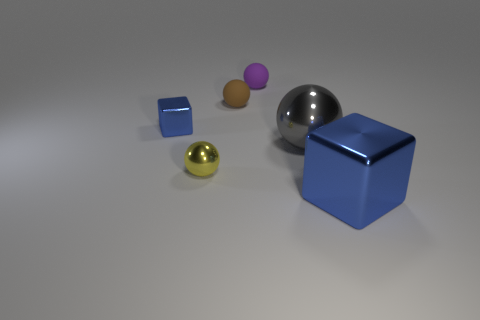Do the small block and the large metallic block have the same color?
Give a very brief answer. Yes. What size is the other metallic cube that is the same color as the large metallic block?
Offer a terse response. Small. Are there fewer tiny yellow metallic things that are right of the tiny purple ball than brown balls right of the small brown sphere?
Offer a terse response. No. Are there any other things that have the same size as the gray object?
Your answer should be compact. Yes. There is a small purple object; what shape is it?
Give a very brief answer. Sphere. What material is the blue block that is left of the tiny purple thing?
Your response must be concise. Metal. There is a metal block right of the tiny shiny thing in front of the blue metallic thing that is on the left side of the large cube; how big is it?
Offer a terse response. Large. Is the material of the blue object that is right of the tiny blue metal object the same as the blue object that is behind the small yellow shiny ball?
Your answer should be compact. Yes. How many other objects are there of the same color as the large cube?
Provide a short and direct response. 1. How many objects are tiny objects on the left side of the small brown sphere or blocks that are to the right of the tiny brown matte ball?
Ensure brevity in your answer.  3. 